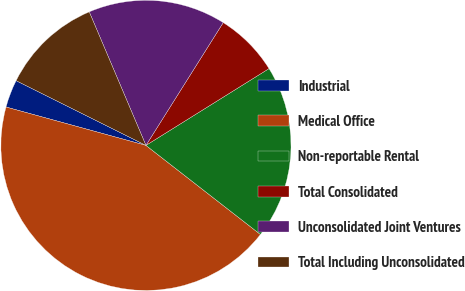Convert chart. <chart><loc_0><loc_0><loc_500><loc_500><pie_chart><fcel>Industrial<fcel>Medical Office<fcel>Non-reportable Rental<fcel>Total Consolidated<fcel>Unconsolidated Joint Ventures<fcel>Total Including Unconsolidated<nl><fcel>3.1%<fcel>43.73%<fcel>19.4%<fcel>7.18%<fcel>15.33%<fcel>11.25%<nl></chart> 